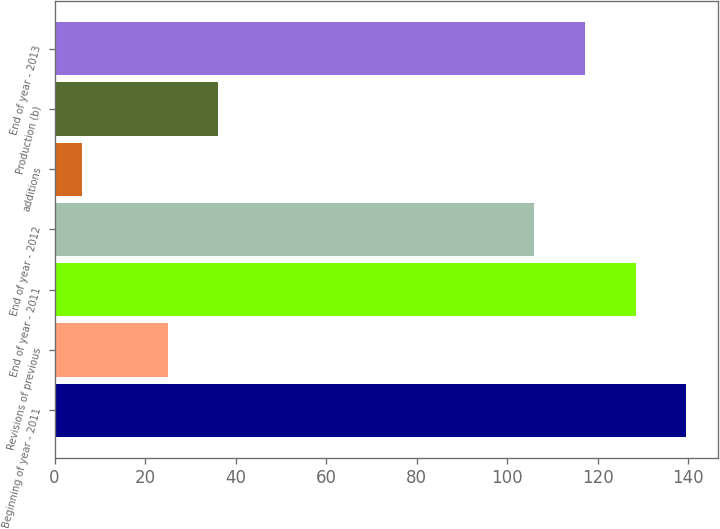<chart> <loc_0><loc_0><loc_500><loc_500><bar_chart><fcel>Beginning of year - 2011<fcel>Revisions of previous<fcel>End of year - 2011<fcel>End of year - 2012<fcel>additions<fcel>Production (b)<fcel>End of year - 2013<nl><fcel>139.6<fcel>25<fcel>128.4<fcel>106<fcel>6<fcel>36.2<fcel>117.2<nl></chart> 